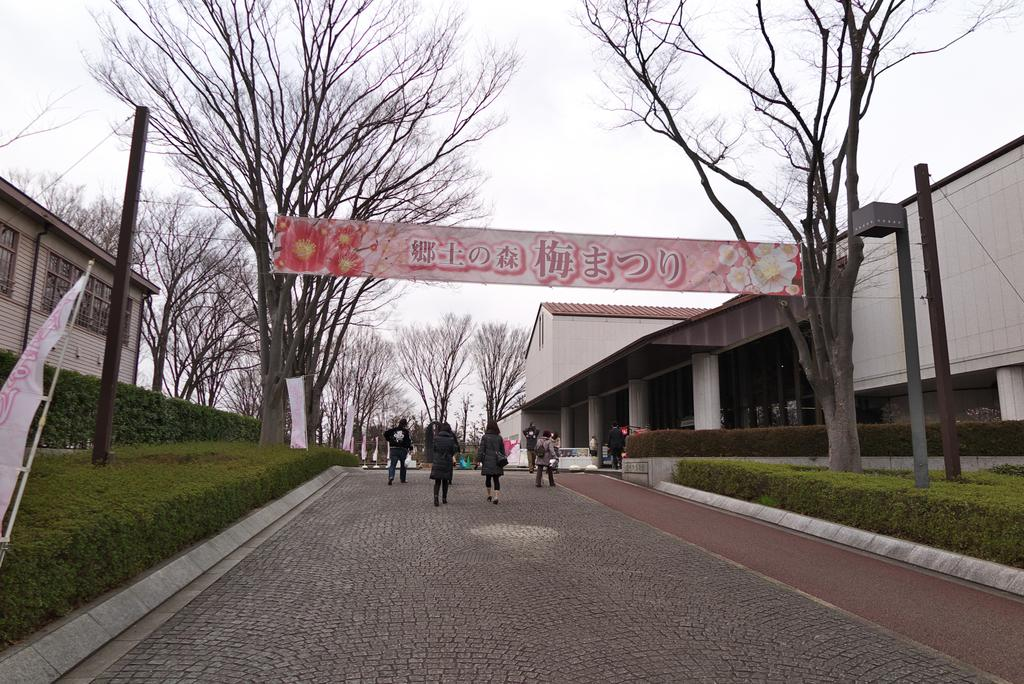How many people can be seen in the image? There is a group of people in the image. What are the people in the image doing? The people are walking on a path. What architectural features are present in the image? There are pillars, buildings with windows, and poles present in the image. What type of vegetation can be seen in the image? There is grass and trees visible in the image. What is visible in the background of the image? The sky is visible in the background of the image. Can you tell me the name of the rose that is being held by one of the people in the image? There is no rose present in the image; it features a group of people walking on a path. What type of battle is depicted in the image? There is no battle depicted in the image; it shows a group of people walking on a path surrounded by various architectural and natural elements. 